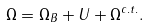<formula> <loc_0><loc_0><loc_500><loc_500>\Omega = \Omega _ { B } + U + \Omega ^ { c . t . } .</formula> 